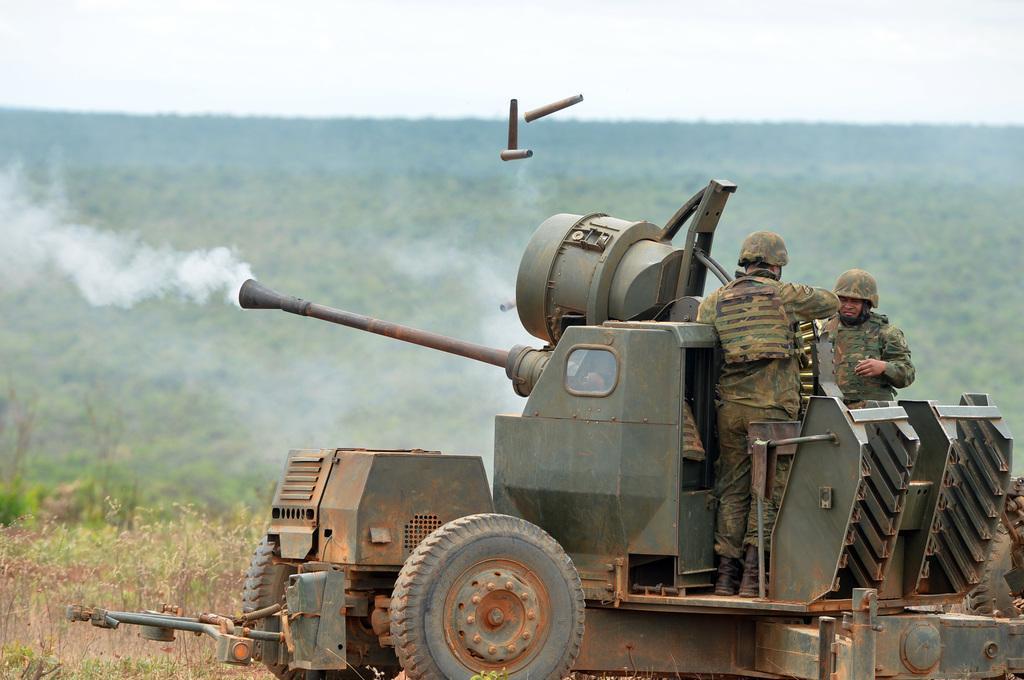Describe this image in one or two sentences. In this picture we can see a military tanker in the middle of the image with two military soldiers standing on the top. Behind we can see the blur background with some trees. 